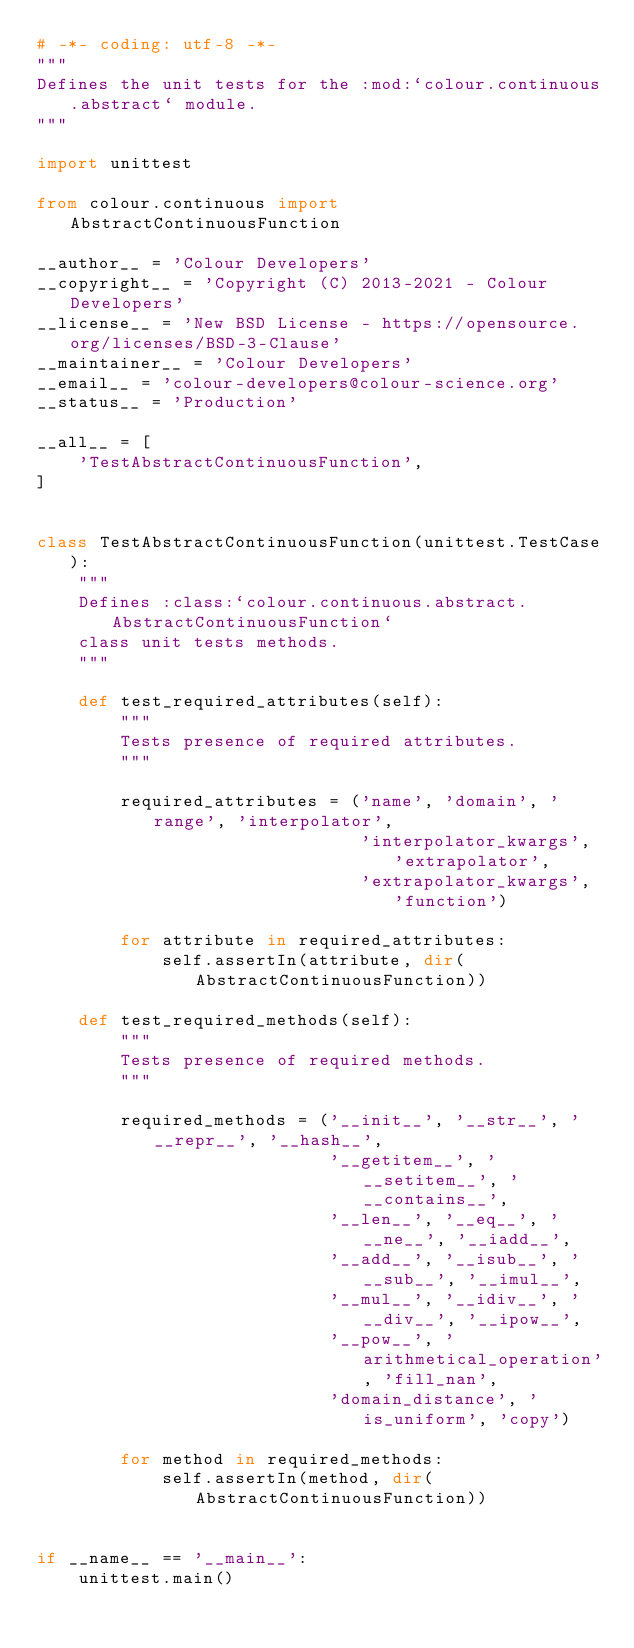Convert code to text. <code><loc_0><loc_0><loc_500><loc_500><_Python_># -*- coding: utf-8 -*-
"""
Defines the unit tests for the :mod:`colour.continuous.abstract` module.
"""

import unittest

from colour.continuous import AbstractContinuousFunction

__author__ = 'Colour Developers'
__copyright__ = 'Copyright (C) 2013-2021 - Colour Developers'
__license__ = 'New BSD License - https://opensource.org/licenses/BSD-3-Clause'
__maintainer__ = 'Colour Developers'
__email__ = 'colour-developers@colour-science.org'
__status__ = 'Production'

__all__ = [
    'TestAbstractContinuousFunction',
]


class TestAbstractContinuousFunction(unittest.TestCase):
    """
    Defines :class:`colour.continuous.abstract.AbstractContinuousFunction`
    class unit tests methods.
    """

    def test_required_attributes(self):
        """
        Tests presence of required attributes.
        """

        required_attributes = ('name', 'domain', 'range', 'interpolator',
                               'interpolator_kwargs', 'extrapolator',
                               'extrapolator_kwargs', 'function')

        for attribute in required_attributes:
            self.assertIn(attribute, dir(AbstractContinuousFunction))

    def test_required_methods(self):
        """
        Tests presence of required methods.
        """

        required_methods = ('__init__', '__str__', '__repr__', '__hash__',
                            '__getitem__', '__setitem__', '__contains__',
                            '__len__', '__eq__', '__ne__', '__iadd__',
                            '__add__', '__isub__', '__sub__', '__imul__',
                            '__mul__', '__idiv__', '__div__', '__ipow__',
                            '__pow__', 'arithmetical_operation', 'fill_nan',
                            'domain_distance', 'is_uniform', 'copy')

        for method in required_methods:
            self.assertIn(method, dir(AbstractContinuousFunction))


if __name__ == '__main__':
    unittest.main()
</code> 